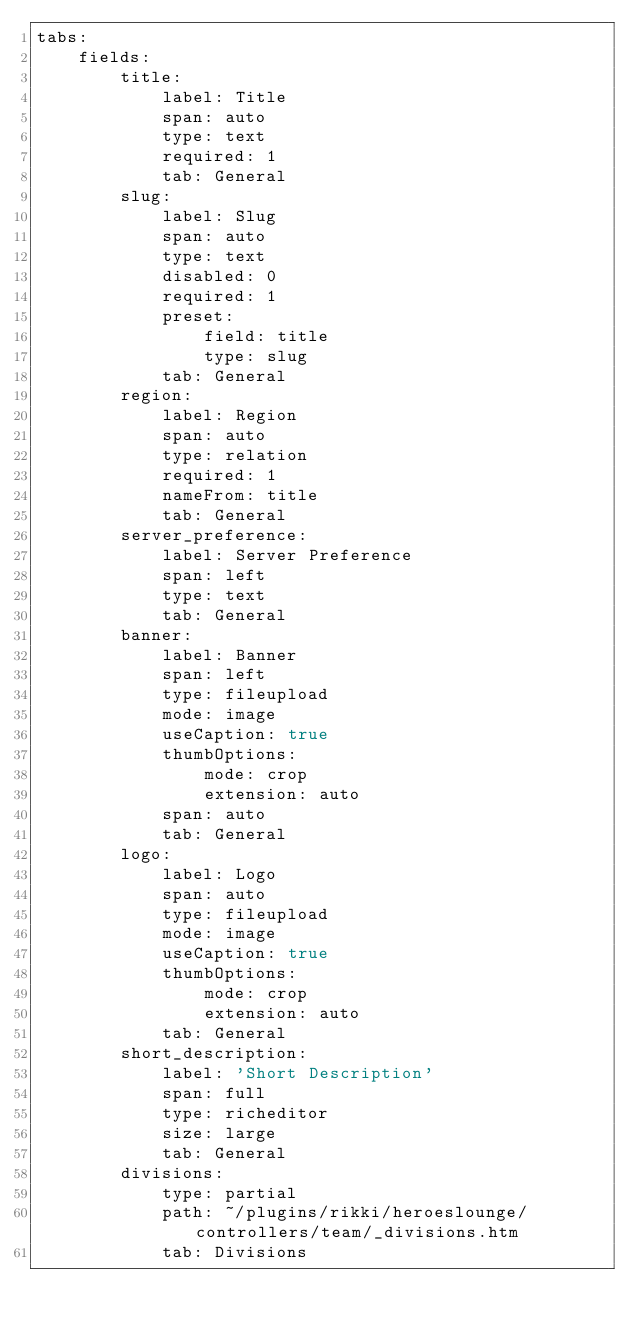<code> <loc_0><loc_0><loc_500><loc_500><_YAML_>tabs:
    fields:
        title:
            label: Title
            span: auto
            type: text
            required: 1
            tab: General
        slug:
            label: Slug
            span: auto
            type: text
            disabled: 0
            required: 1
            preset:
                field: title
                type: slug
            tab: General
        region:
            label: Region
            span: auto
            type: relation
            required: 1
            nameFrom: title
            tab: General
        server_preference:
            label: Server Preference
            span: left
            type: text
            tab: General
        banner:
            label: Banner
            span: left
            type: fileupload
            mode: image
            useCaption: true
            thumbOptions:
                mode: crop
                extension: auto
            span: auto
            tab: General
        logo:
            label: Logo
            span: auto
            type: fileupload
            mode: image
            useCaption: true
            thumbOptions:
                mode: crop
                extension: auto
            tab: General
        short_description:
            label: 'Short Description'
            span: full
            type: richeditor
            size: large
            tab: General
        divisions:
            type: partial
            path: ~/plugins/rikki/heroeslounge/controllers/team/_divisions.htm
            tab: Divisions
</code> 